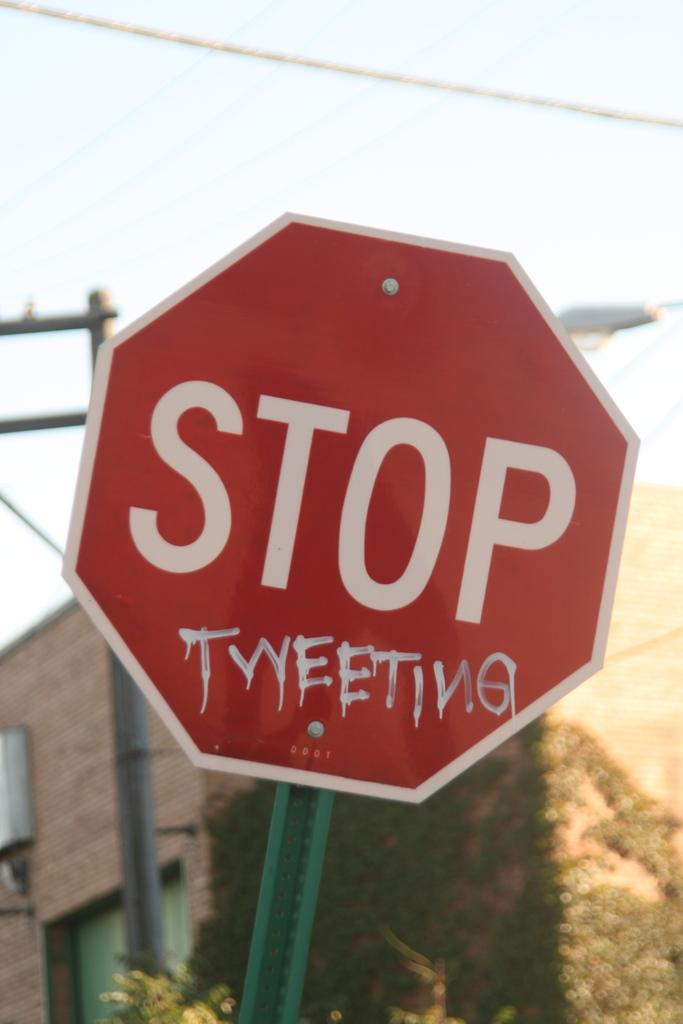Provide a one-sentence caption for the provided image. A red STOP sign has the phrase "tweeting" sprawled right below it. 